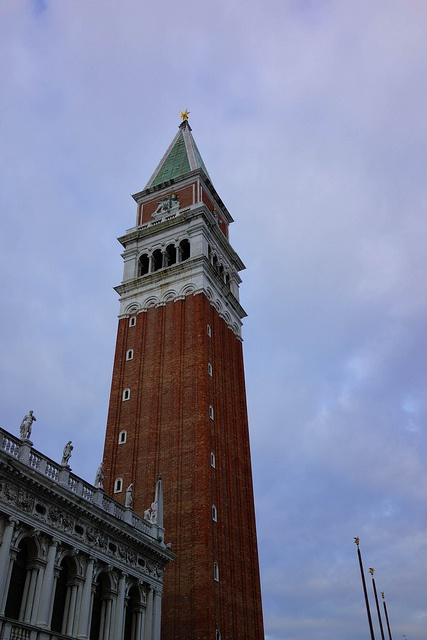Describe the objects in this image and their specific colors. I can see various objects in this image with different colors. 